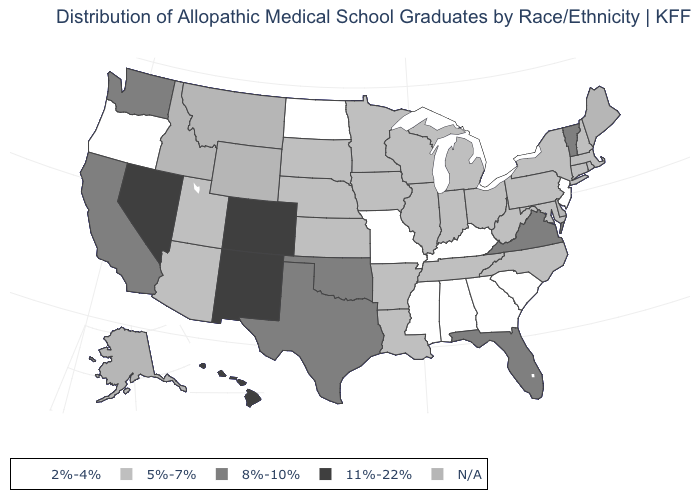What is the value of West Virginia?
Give a very brief answer. 5%-7%. What is the value of Wisconsin?
Give a very brief answer. 5%-7%. What is the value of Rhode Island?
Short answer required. 5%-7%. What is the lowest value in the USA?
Concise answer only. 2%-4%. Which states have the lowest value in the West?
Answer briefly. Oregon. What is the value of Utah?
Write a very short answer. 5%-7%. Name the states that have a value in the range N/A?
Short answer required. Alaska, Delaware, Idaho, Maine, Montana, Wyoming. Which states have the highest value in the USA?
Answer briefly. Colorado, Hawaii, Nevada, New Mexico. What is the highest value in the USA?
Answer briefly. 11%-22%. What is the lowest value in the West?
Short answer required. 2%-4%. Name the states that have a value in the range 11%-22%?
Answer briefly. Colorado, Hawaii, Nevada, New Mexico. Is the legend a continuous bar?
Give a very brief answer. No. Name the states that have a value in the range 8%-10%?
Keep it brief. California, Florida, Oklahoma, Texas, Vermont, Virginia, Washington. What is the value of Hawaii?
Give a very brief answer. 11%-22%. 